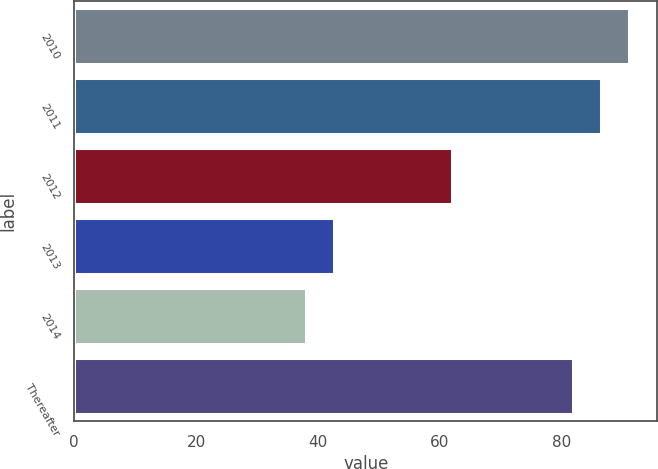Convert chart to OTSL. <chart><loc_0><loc_0><loc_500><loc_500><bar_chart><fcel>2010<fcel>2011<fcel>2012<fcel>2013<fcel>2014<fcel>Thereafter<nl><fcel>91.2<fcel>86.6<fcel>62<fcel>42.6<fcel>38<fcel>82<nl></chart> 